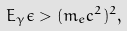<formula> <loc_0><loc_0><loc_500><loc_500>E _ { \gamma } \epsilon > ( m _ { e } c ^ { 2 } ) ^ { 2 } ,</formula> 